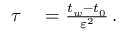<formula> <loc_0><loc_0><loc_500><loc_500>\begin{array} { r l } { \tau } & = \frac { t _ { w } - t _ { 0 } } { { \varepsilon } ^ { 2 } } \, . } \end{array}</formula> 